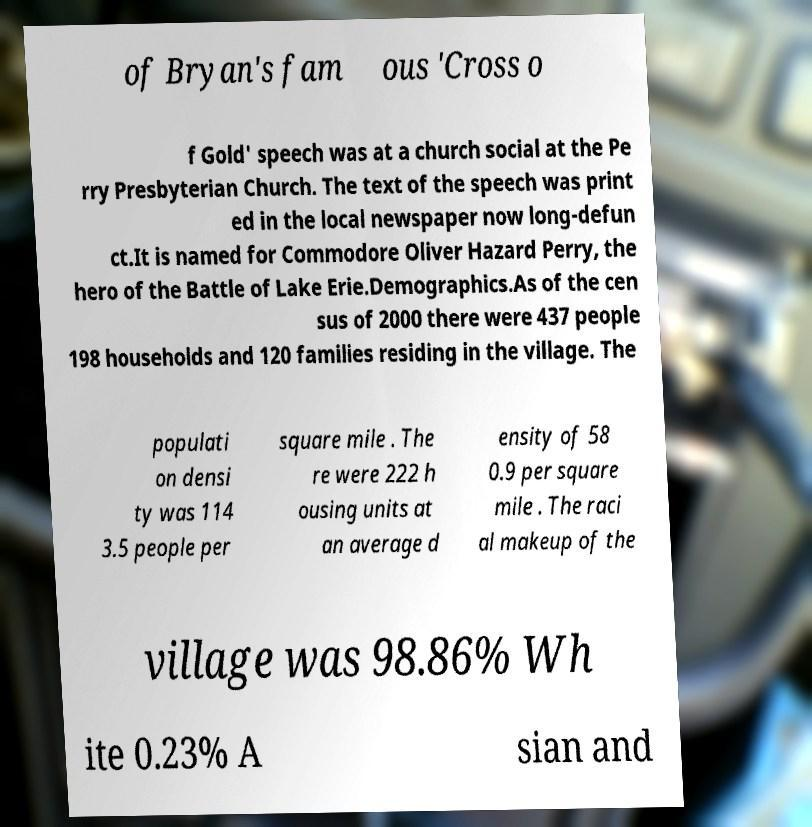Could you extract and type out the text from this image? of Bryan's fam ous 'Cross o f Gold' speech was at a church social at the Pe rry Presbyterian Church. The text of the speech was print ed in the local newspaper now long-defun ct.It is named for Commodore Oliver Hazard Perry, the hero of the Battle of Lake Erie.Demographics.As of the cen sus of 2000 there were 437 people 198 households and 120 families residing in the village. The populati on densi ty was 114 3.5 people per square mile . The re were 222 h ousing units at an average d ensity of 58 0.9 per square mile . The raci al makeup of the village was 98.86% Wh ite 0.23% A sian and 